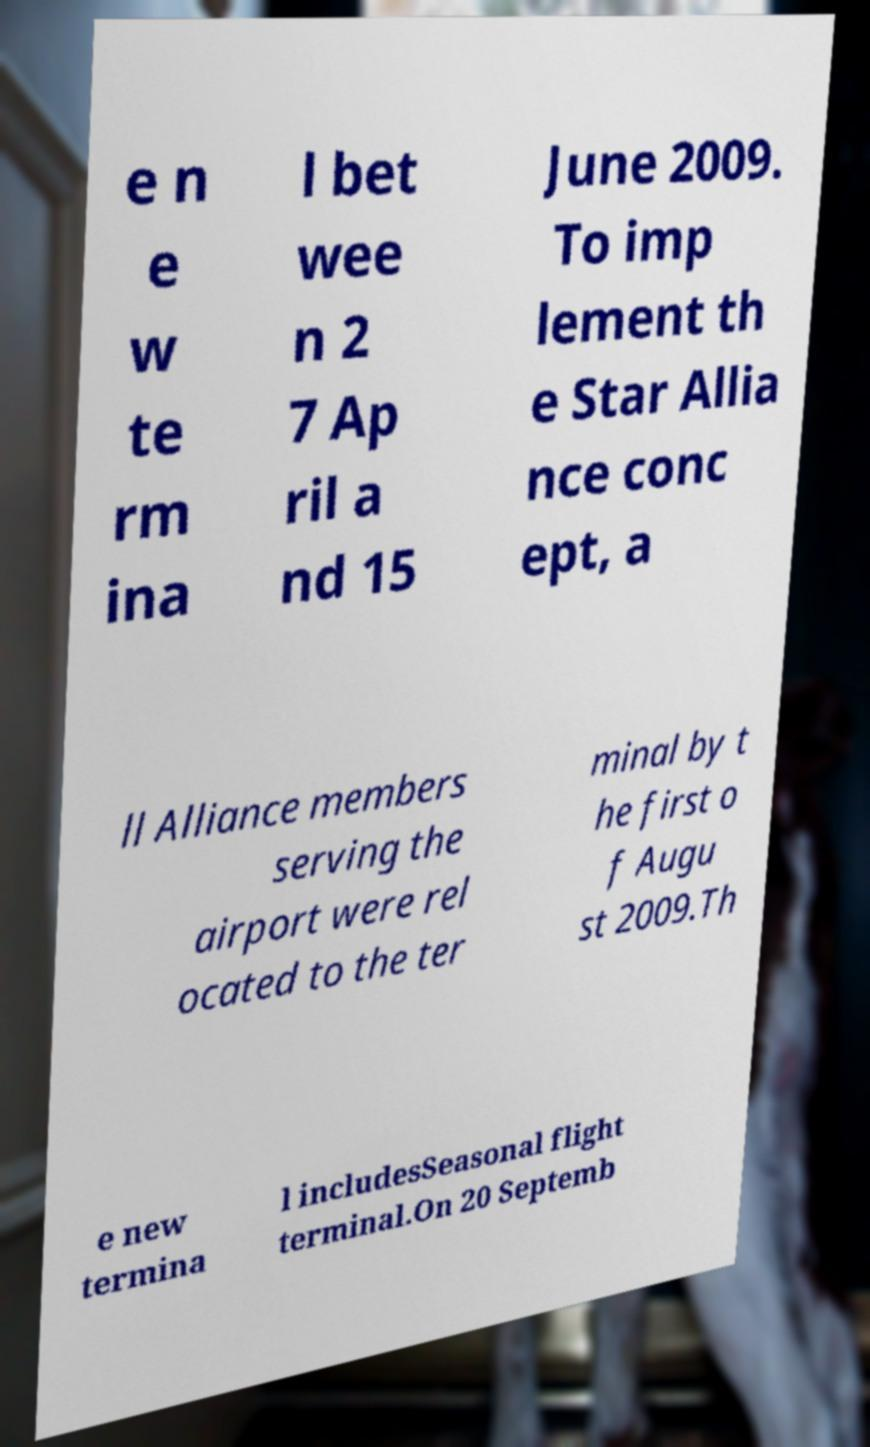Could you extract and type out the text from this image? e n e w te rm ina l bet wee n 2 7 Ap ril a nd 15 June 2009. To imp lement th e Star Allia nce conc ept, a ll Alliance members serving the airport were rel ocated to the ter minal by t he first o f Augu st 2009.Th e new termina l includesSeasonal flight terminal.On 20 Septemb 